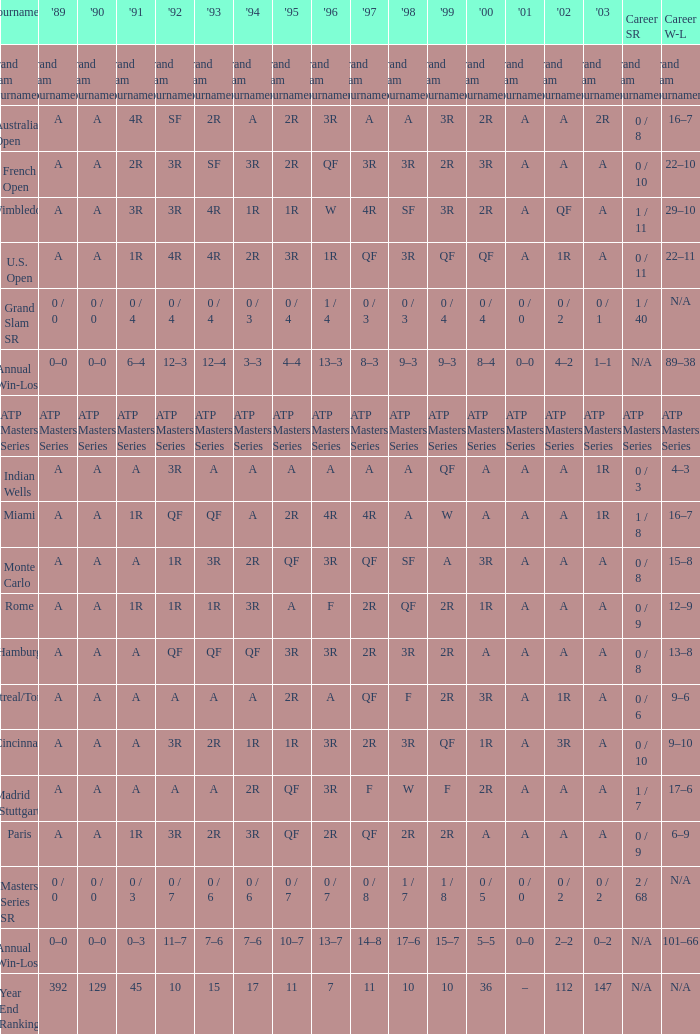What was the value in 1995 for A in 2000 at the Indian Wells tournament? A. 